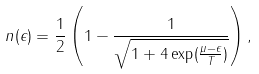Convert formula to latex. <formula><loc_0><loc_0><loc_500><loc_500>n ( \epsilon ) = \frac { 1 } { 2 } \left ( 1 - \frac { 1 } { \sqrt { 1 + 4 \exp ( \frac { \mu - \epsilon } { T } ) } } \right ) ,</formula> 